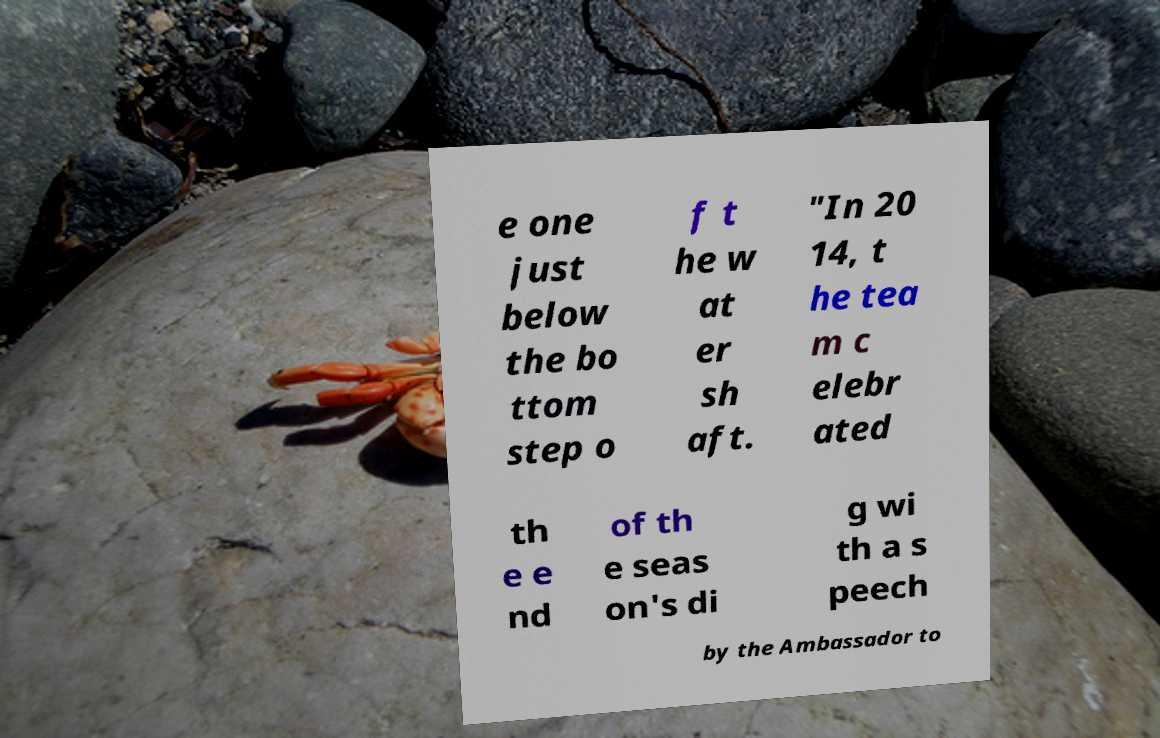For documentation purposes, I need the text within this image transcribed. Could you provide that? e one just below the bo ttom step o f t he w at er sh aft. "In 20 14, t he tea m c elebr ated th e e nd of th e seas on's di g wi th a s peech by the Ambassador to 